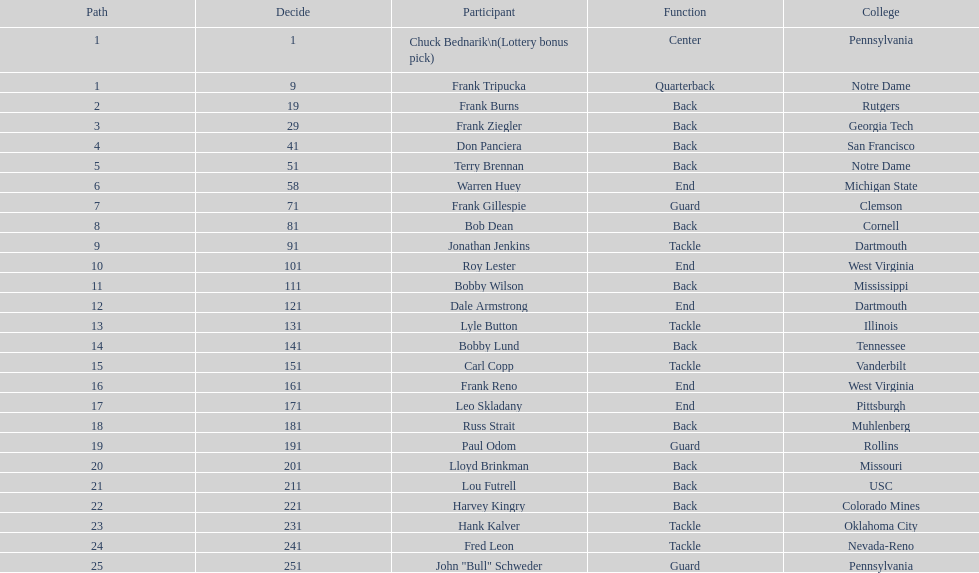Highest rd number? 25. Parse the table in full. {'header': ['Path', 'Decide', 'Participant', 'Function', 'College'], 'rows': [['1', '1', 'Chuck Bednarik\\n(Lottery bonus pick)', 'Center', 'Pennsylvania'], ['1', '9', 'Frank Tripucka', 'Quarterback', 'Notre Dame'], ['2', '19', 'Frank Burns', 'Back', 'Rutgers'], ['3', '29', 'Frank Ziegler', 'Back', 'Georgia Tech'], ['4', '41', 'Don Panciera', 'Back', 'San Francisco'], ['5', '51', 'Terry Brennan', 'Back', 'Notre Dame'], ['6', '58', 'Warren Huey', 'End', 'Michigan State'], ['7', '71', 'Frank Gillespie', 'Guard', 'Clemson'], ['8', '81', 'Bob Dean', 'Back', 'Cornell'], ['9', '91', 'Jonathan Jenkins', 'Tackle', 'Dartmouth'], ['10', '101', 'Roy Lester', 'End', 'West Virginia'], ['11', '111', 'Bobby Wilson', 'Back', 'Mississippi'], ['12', '121', 'Dale Armstrong', 'End', 'Dartmouth'], ['13', '131', 'Lyle Button', 'Tackle', 'Illinois'], ['14', '141', 'Bobby Lund', 'Back', 'Tennessee'], ['15', '151', 'Carl Copp', 'Tackle', 'Vanderbilt'], ['16', '161', 'Frank Reno', 'End', 'West Virginia'], ['17', '171', 'Leo Skladany', 'End', 'Pittsburgh'], ['18', '181', 'Russ Strait', 'Back', 'Muhlenberg'], ['19', '191', 'Paul Odom', 'Guard', 'Rollins'], ['20', '201', 'Lloyd Brinkman', 'Back', 'Missouri'], ['21', '211', 'Lou Futrell', 'Back', 'USC'], ['22', '221', 'Harvey Kingry', 'Back', 'Colorado Mines'], ['23', '231', 'Hank Kalver', 'Tackle', 'Oklahoma City'], ['24', '241', 'Fred Leon', 'Tackle', 'Nevada-Reno'], ['25', '251', 'John "Bull" Schweder', 'Guard', 'Pennsylvania']]} 